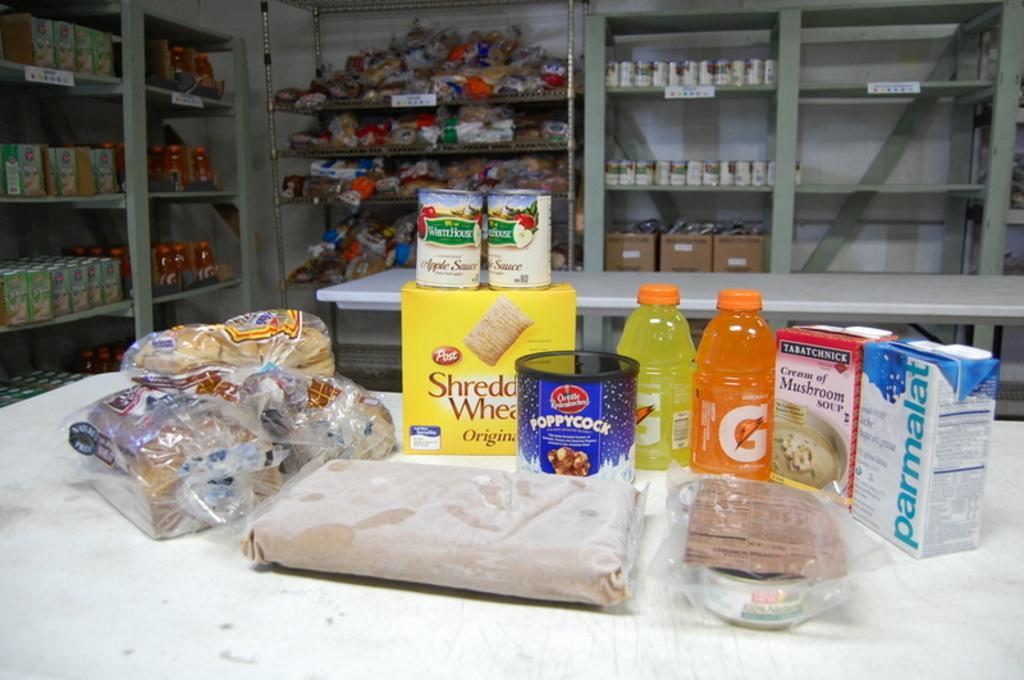<image>
Provide a brief description of the given image. A box of Shredded Wheats and other food products are laid out on a table. 